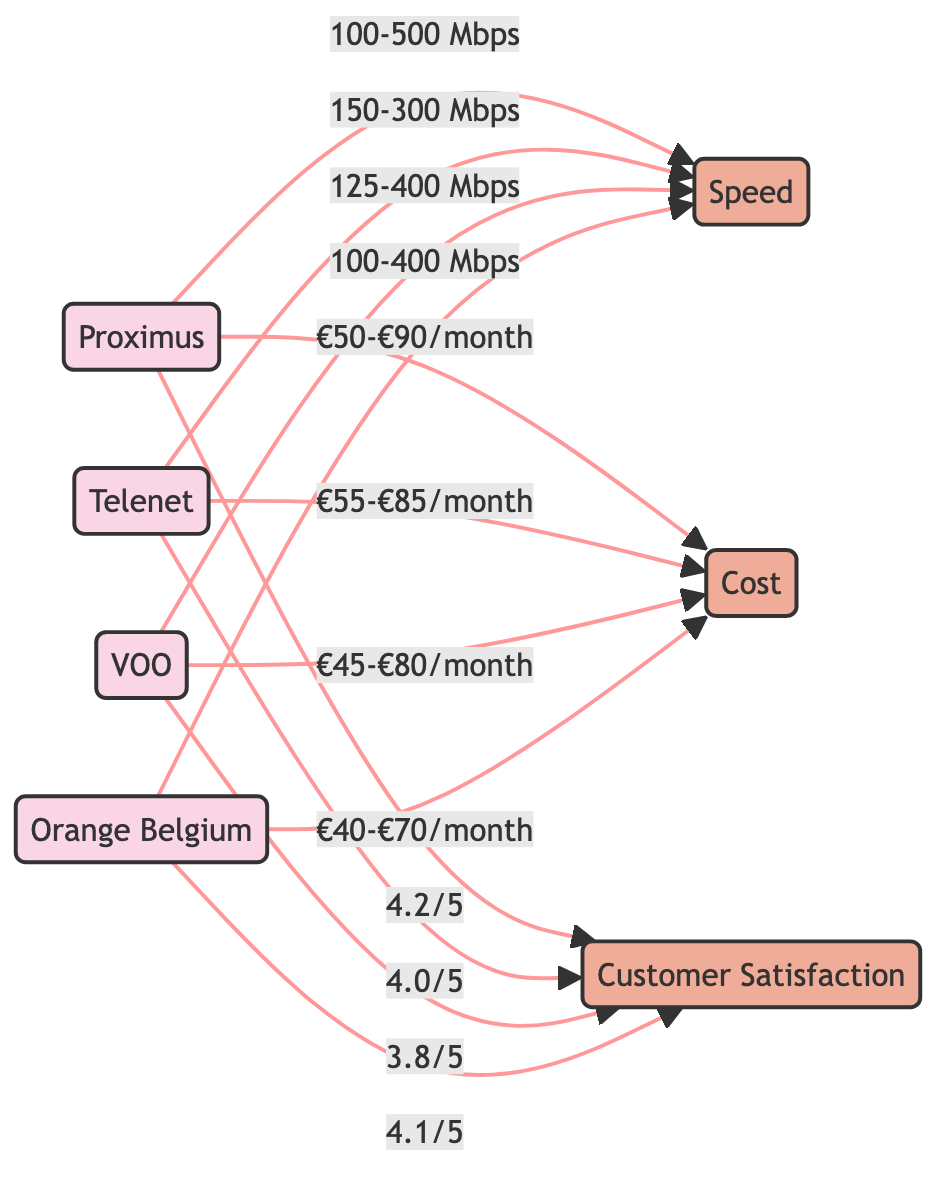What is the maximum speed offered by Proximus? The diagram shows that the speed range offered by Proximus is 100-500 Mbps, where 500 Mbps is the maximum speed.
Answer: 500 Mbps What is the minimum cost for Orange Belgium? According to the diagram, the cost range for Orange Belgium is €40-€70/month, where €40 is the minimum cost listed.
Answer: €40/month How many broadband providers are compared in this diagram? The diagram lists four providers: Proximus, Telenet, VOO, and Orange Belgium, which counts to four providers in total.
Answer: 4 Which provider has the highest customer satisfaction rating? From the diagram, Proximus has a customer satisfaction rating of 4.2/5, which is higher than other providers' ratings.
Answer: Proximus What is the cost range for VOO? The diagram specifies that VOO's cost range is between €45 and €80 per month.
Answer: €45-€80/month What is the speed range for Telenet? Telenet offers a speed range of 150-300 Mbps, as indicated in the diagram.
Answer: 150-300 Mbps Which provider has the lowest customer satisfaction? VOO has the lowest customer satisfaction rating of 3.8/5, compared to other providers in the diagram.
Answer: VOO What is the relationship between customer satisfaction and cost for Orange Belgium? The diagram shows Orange Belgium offers a cost range of €40-€70/month and a customer satisfaction rating of 4.1/5, indicating a positive relationship.
Answer: 4.1/5, €40-€70/month What is the average speed range of all providers? To find the average speed, we can consider the ranges; Proximus (100-500 Mbps), Telenet (150-300 Mbps), VOO (125-400 Mbps), and Orange (100-400 Mbps). Averaging the lower and upper limits provides a rough range of 100-500 Mbps, as it's similar across providers.
Answer: 100-500 Mbps 